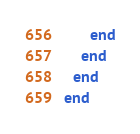Convert code to text. <code><loc_0><loc_0><loc_500><loc_500><_Ruby_>      end
    end
  end
end
</code> 